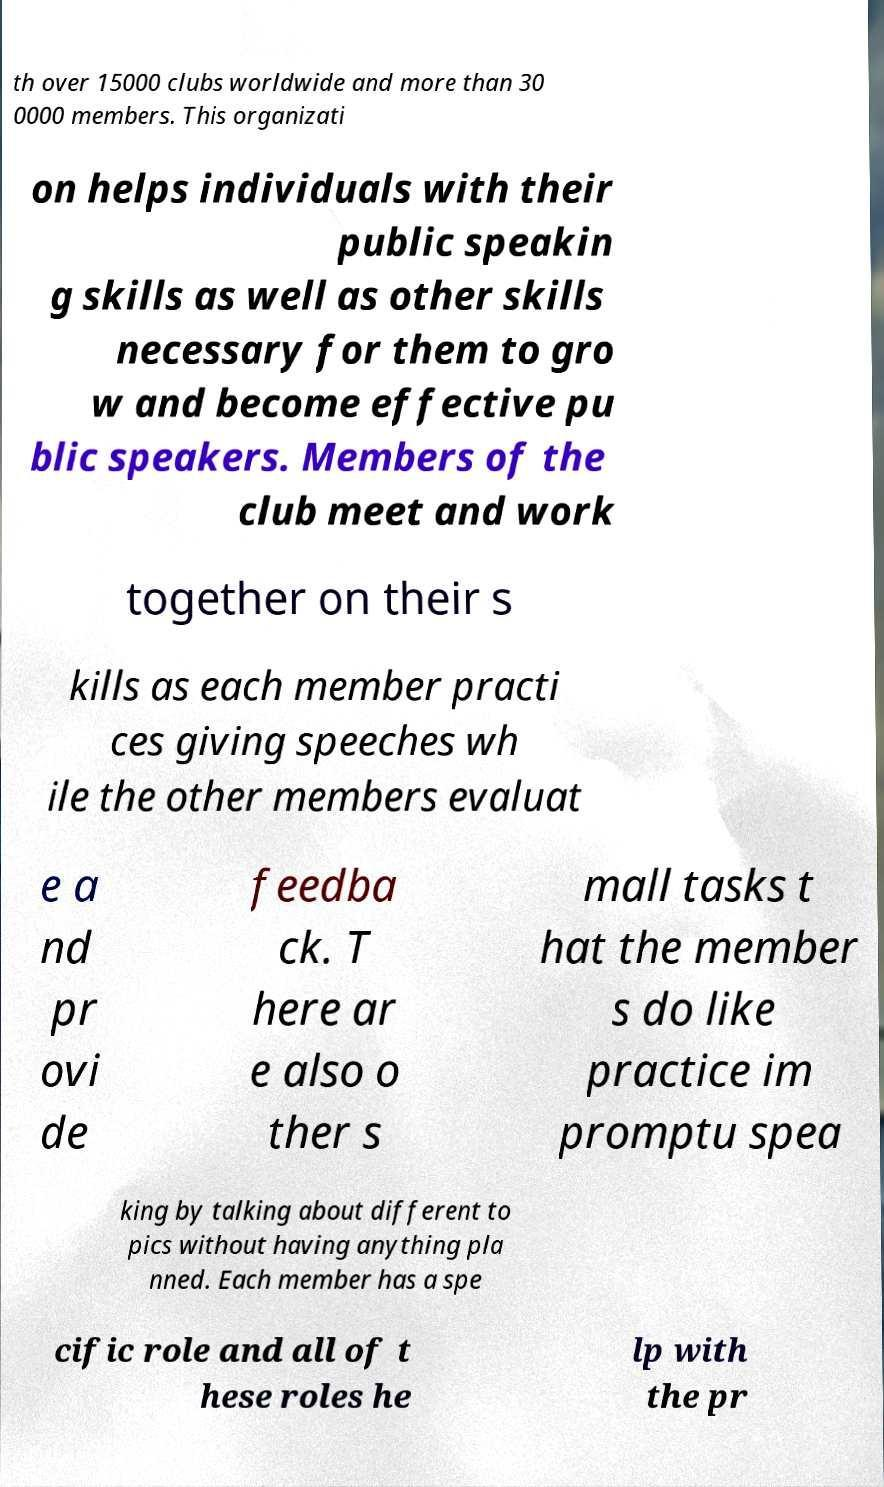I need the written content from this picture converted into text. Can you do that? th over 15000 clubs worldwide and more than 30 0000 members. This organizati on helps individuals with their public speakin g skills as well as other skills necessary for them to gro w and become effective pu blic speakers. Members of the club meet and work together on their s kills as each member practi ces giving speeches wh ile the other members evaluat e a nd pr ovi de feedba ck. T here ar e also o ther s mall tasks t hat the member s do like practice im promptu spea king by talking about different to pics without having anything pla nned. Each member has a spe cific role and all of t hese roles he lp with the pr 